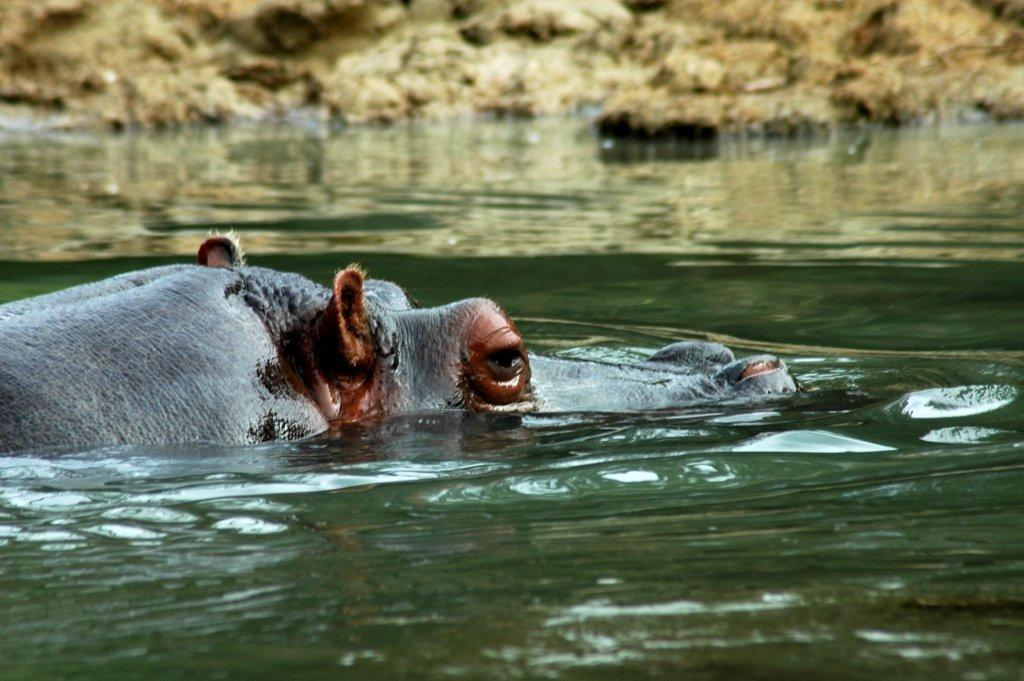What type of animal is in the image? There is a hippopotamus in the image. Can you describe the setting in which the hippopotamus is located? The hippopotamus is in water. What type of range can be seen in the image? There is no range present in the image; it features a hippopotamus in water. What time is displayed on the clock in the image? There is no clock present in the image. 